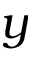<formula> <loc_0><loc_0><loc_500><loc_500>y</formula> 